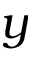<formula> <loc_0><loc_0><loc_500><loc_500>y</formula> 